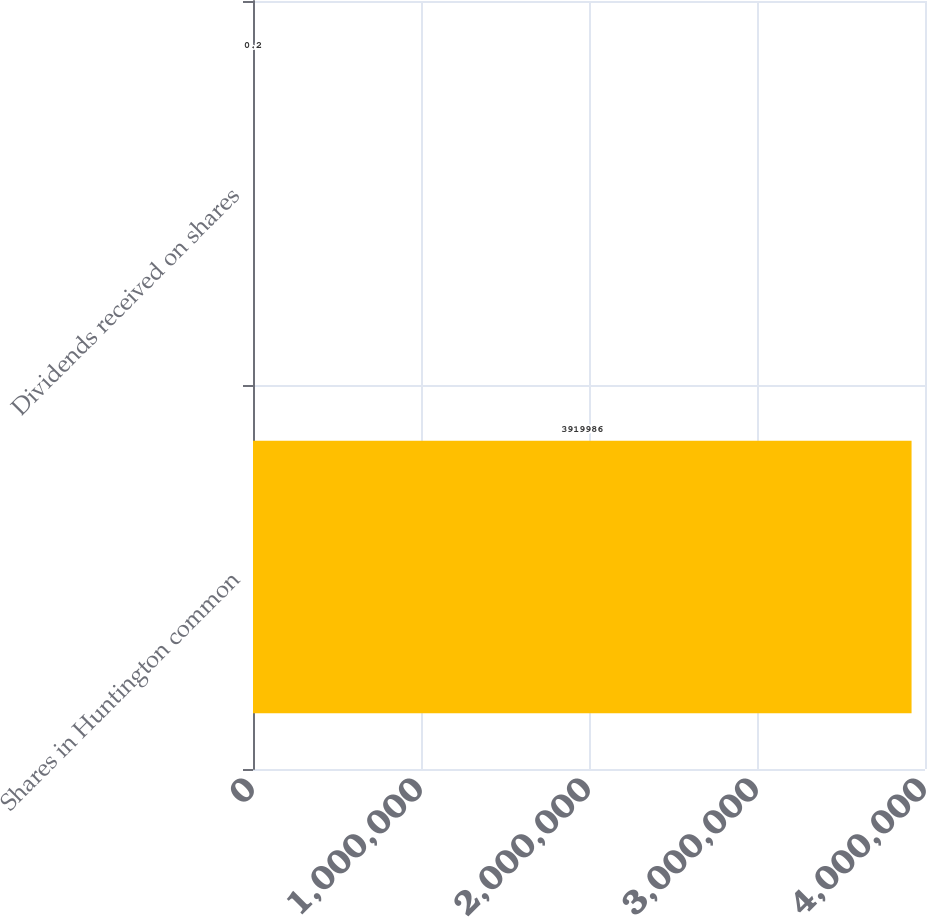Convert chart. <chart><loc_0><loc_0><loc_500><loc_500><bar_chart><fcel>Shares in Huntington common<fcel>Dividends received on shares<nl><fcel>3.91999e+06<fcel>0.2<nl></chart> 